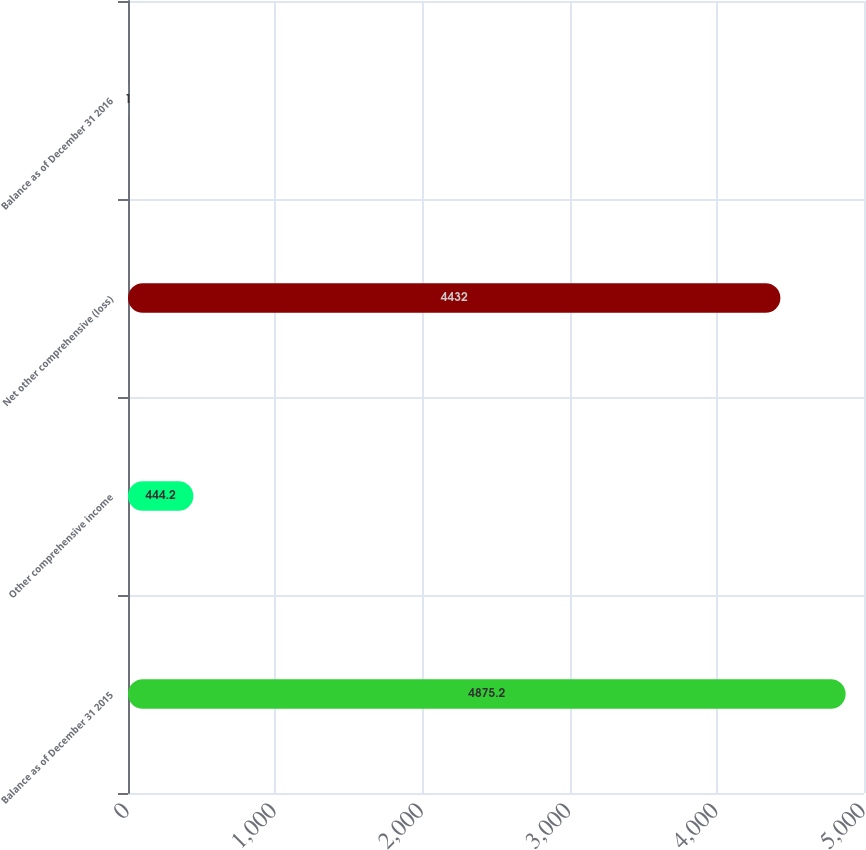Convert chart. <chart><loc_0><loc_0><loc_500><loc_500><bar_chart><fcel>Balance as of December 31 2015<fcel>Other comprehensive income<fcel>Net other comprehensive (loss)<fcel>Balance as of December 31 2016<nl><fcel>4875.2<fcel>444.2<fcel>4432<fcel>1<nl></chart> 